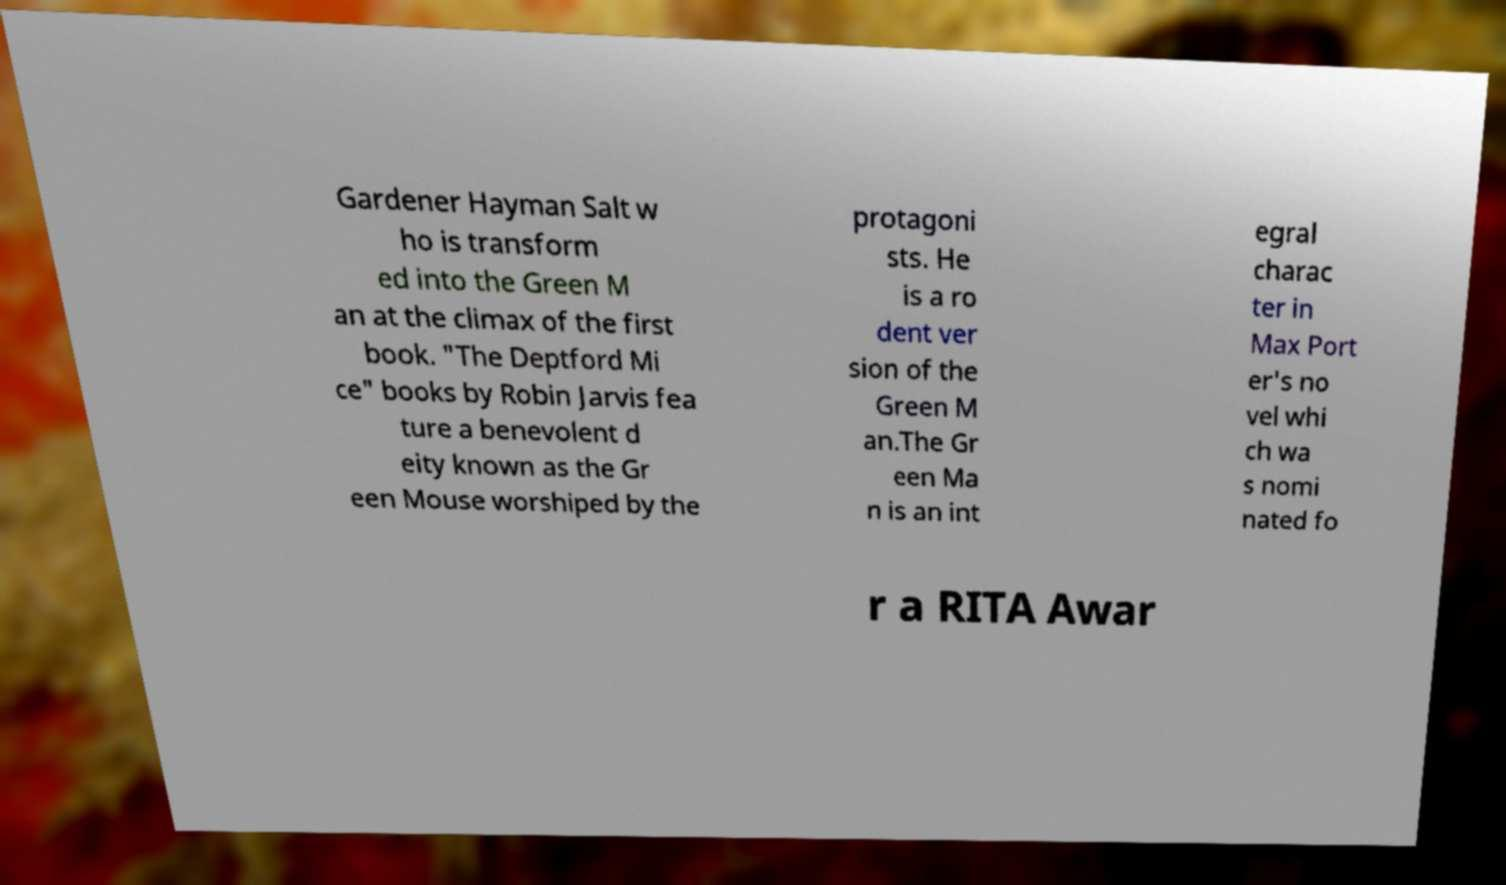What messages or text are displayed in this image? I need them in a readable, typed format. Gardener Hayman Salt w ho is transform ed into the Green M an at the climax of the first book. "The Deptford Mi ce" books by Robin Jarvis fea ture a benevolent d eity known as the Gr een Mouse worshiped by the protagoni sts. He is a ro dent ver sion of the Green M an.The Gr een Ma n is an int egral charac ter in Max Port er's no vel whi ch wa s nomi nated fo r a RITA Awar 